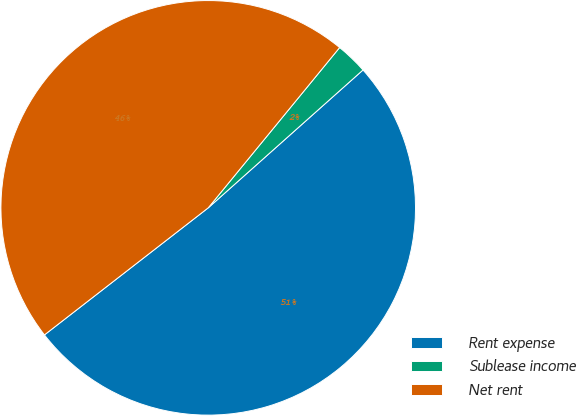<chart> <loc_0><loc_0><loc_500><loc_500><pie_chart><fcel>Rent expense<fcel>Sublease income<fcel>Net rent<nl><fcel>51.08%<fcel>2.49%<fcel>46.43%<nl></chart> 